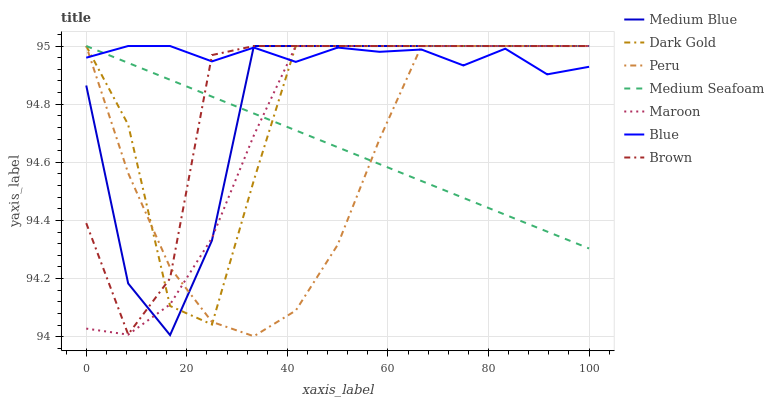Does Peru have the minimum area under the curve?
Answer yes or no. Yes. Does Blue have the maximum area under the curve?
Answer yes or no. Yes. Does Brown have the minimum area under the curve?
Answer yes or no. No. Does Brown have the maximum area under the curve?
Answer yes or no. No. Is Medium Seafoam the smoothest?
Answer yes or no. Yes. Is Medium Blue the roughest?
Answer yes or no. Yes. Is Brown the smoothest?
Answer yes or no. No. Is Brown the roughest?
Answer yes or no. No. Does Peru have the lowest value?
Answer yes or no. Yes. Does Brown have the lowest value?
Answer yes or no. No. Does Medium Seafoam have the highest value?
Answer yes or no. Yes. Does Brown intersect Peru?
Answer yes or no. Yes. Is Brown less than Peru?
Answer yes or no. No. Is Brown greater than Peru?
Answer yes or no. No. 